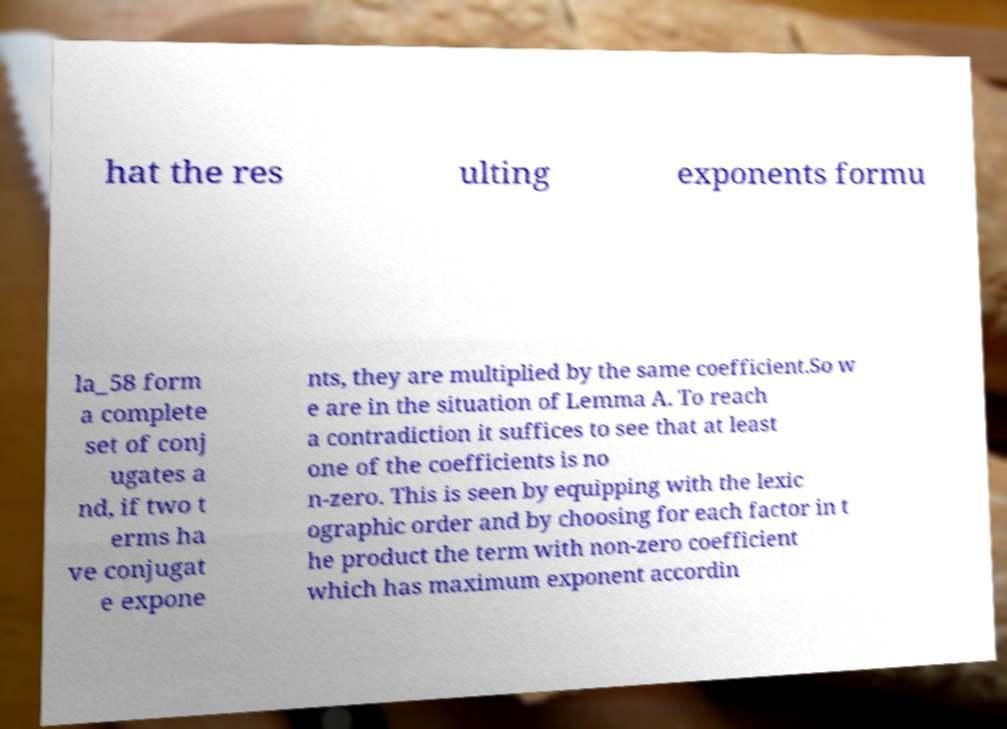Could you assist in decoding the text presented in this image and type it out clearly? hat the res ulting exponents formu la_58 form a complete set of conj ugates a nd, if two t erms ha ve conjugat e expone nts, they are multiplied by the same coefficient.So w e are in the situation of Lemma A. To reach a contradiction it suffices to see that at least one of the coefficients is no n-zero. This is seen by equipping with the lexic ographic order and by choosing for each factor in t he product the term with non-zero coefficient which has maximum exponent accordin 